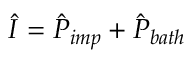<formula> <loc_0><loc_0><loc_500><loc_500>\hat { I } = \hat { P } _ { i m p } + \hat { P } _ { b a t h }</formula> 